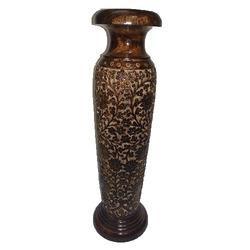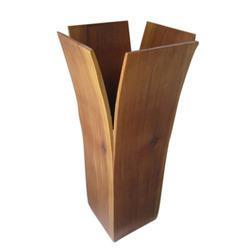The first image is the image on the left, the second image is the image on the right. Given the left and right images, does the statement "In one image, a single vase has four box-like sides that are smaller at the bottom than at the top, while one vase in a second image is dark brown and curved." hold true? Answer yes or no. Yes. The first image is the image on the left, the second image is the image on the right. For the images displayed, is the sentence "There is one empty vase in the image on the right." factually correct? Answer yes or no. Yes. 